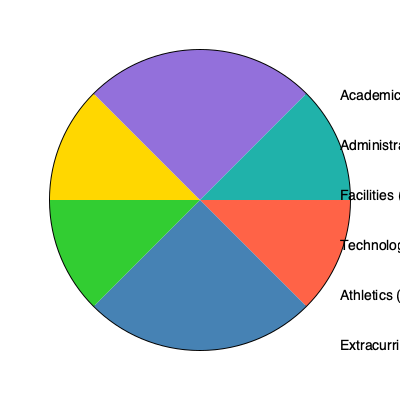Based on the pie chart depicting the school budget allocation, which two departments combined account for 55% of the total budget? How might this allocation reflect the school's priorities, and what potential implications could this have on decision-making for resource distribution? To answer this question, we need to analyze the percentages given in the pie chart and identify the two departments that sum to 55% of the total budget. Let's break it down step-by-step:

1. Examine the percentages for each department:
   - Academic: 30%
   - Administrative: 25%
   - Facilities: 15%
   - Technology: 12%
   - Athletics: 10%
   - Extracurricular: 8%

2. Identify the combination that adds up to 55%:
   Academic (30%) + Administrative (25%) = 55%

3. Analyze the implications of this allocation:
   a) Priorities: This allocation suggests that the school prioritizes academic programs and administrative functions, which together comprise more than half of the total budget.
   
   b) Focus on core educational mission: The significant investment in academics (30%) indicates a strong emphasis on teaching and learning, which aligns with the primary goal of educational institutions.
   
   c) Administrative support: The substantial allocation to administrative functions (25%) suggests recognition of the importance of efficient management and support services for the school's operations.
   
   d) Decision-making implications:
      - Resource distribution: With 55% of the budget allocated to these two areas, there may be limited flexibility for significant increases in other departments without adjusting the academic or administrative budgets.
      - Balancing act: The principal must carefully consider how to maintain the quality of academic programs and administrative efficiency while also addressing the needs of other departments.
      - Justification: Any proposals for major expenditures in other areas (e.g., facilities upgrades or technology investments) may require strong justification and potentially creative funding solutions.
      - Long-term planning: The principal should consider whether this allocation aligns with the school's long-term strategic goals and if any adjustments are needed over time to support emerging priorities or address underserved areas.

This allocation reflects a school that values its core educational mission and the administrative structure to support it, but it also requires careful consideration of how to meet the needs of other important areas such as facilities, technology, athletics, and extracurricular activities within the remaining 45% of the budget.
Answer: Academic and Administrative; prioritizes core education and management, requires careful balancing of resources. 